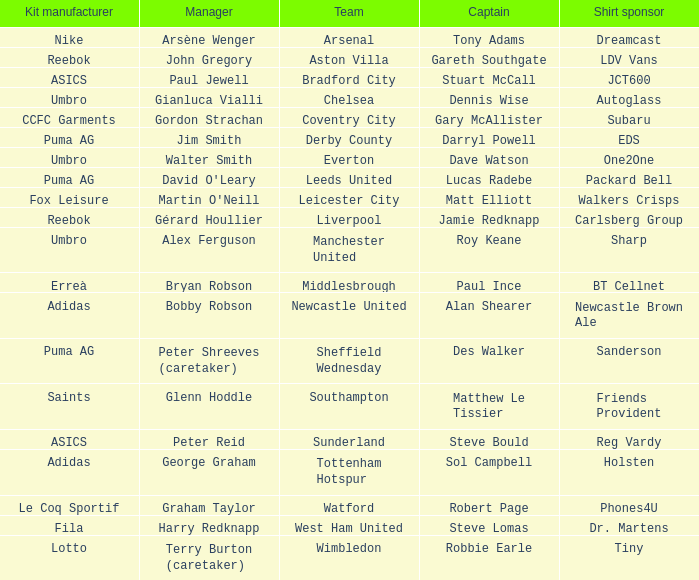Could you help me parse every detail presented in this table? {'header': ['Kit manufacturer', 'Manager', 'Team', 'Captain', 'Shirt sponsor'], 'rows': [['Nike', 'Arsène Wenger', 'Arsenal', 'Tony Adams', 'Dreamcast'], ['Reebok', 'John Gregory', 'Aston Villa', 'Gareth Southgate', 'LDV Vans'], ['ASICS', 'Paul Jewell', 'Bradford City', 'Stuart McCall', 'JCT600'], ['Umbro', 'Gianluca Vialli', 'Chelsea', 'Dennis Wise', 'Autoglass'], ['CCFC Garments', 'Gordon Strachan', 'Coventry City', 'Gary McAllister', 'Subaru'], ['Puma AG', 'Jim Smith', 'Derby County', 'Darryl Powell', 'EDS'], ['Umbro', 'Walter Smith', 'Everton', 'Dave Watson', 'One2One'], ['Puma AG', "David O'Leary", 'Leeds United', 'Lucas Radebe', 'Packard Bell'], ['Fox Leisure', "Martin O'Neill", 'Leicester City', 'Matt Elliott', 'Walkers Crisps'], ['Reebok', 'Gérard Houllier', 'Liverpool', 'Jamie Redknapp', 'Carlsberg Group'], ['Umbro', 'Alex Ferguson', 'Manchester United', 'Roy Keane', 'Sharp'], ['Erreà', 'Bryan Robson', 'Middlesbrough', 'Paul Ince', 'BT Cellnet'], ['Adidas', 'Bobby Robson', 'Newcastle United', 'Alan Shearer', 'Newcastle Brown Ale'], ['Puma AG', 'Peter Shreeves (caretaker)', 'Sheffield Wednesday', 'Des Walker', 'Sanderson'], ['Saints', 'Glenn Hoddle', 'Southampton', 'Matthew Le Tissier', 'Friends Provident'], ['ASICS', 'Peter Reid', 'Sunderland', 'Steve Bould', 'Reg Vardy'], ['Adidas', 'George Graham', 'Tottenham Hotspur', 'Sol Campbell', 'Holsten'], ['Le Coq Sportif', 'Graham Taylor', 'Watford', 'Robert Page', 'Phones4U'], ['Fila', 'Harry Redknapp', 'West Ham United', 'Steve Lomas', 'Dr. Martens'], ['Lotto', 'Terry Burton (caretaker)', 'Wimbledon', 'Robbie Earle', 'Tiny']]} Which team does David O'leary manage? Leeds United. 